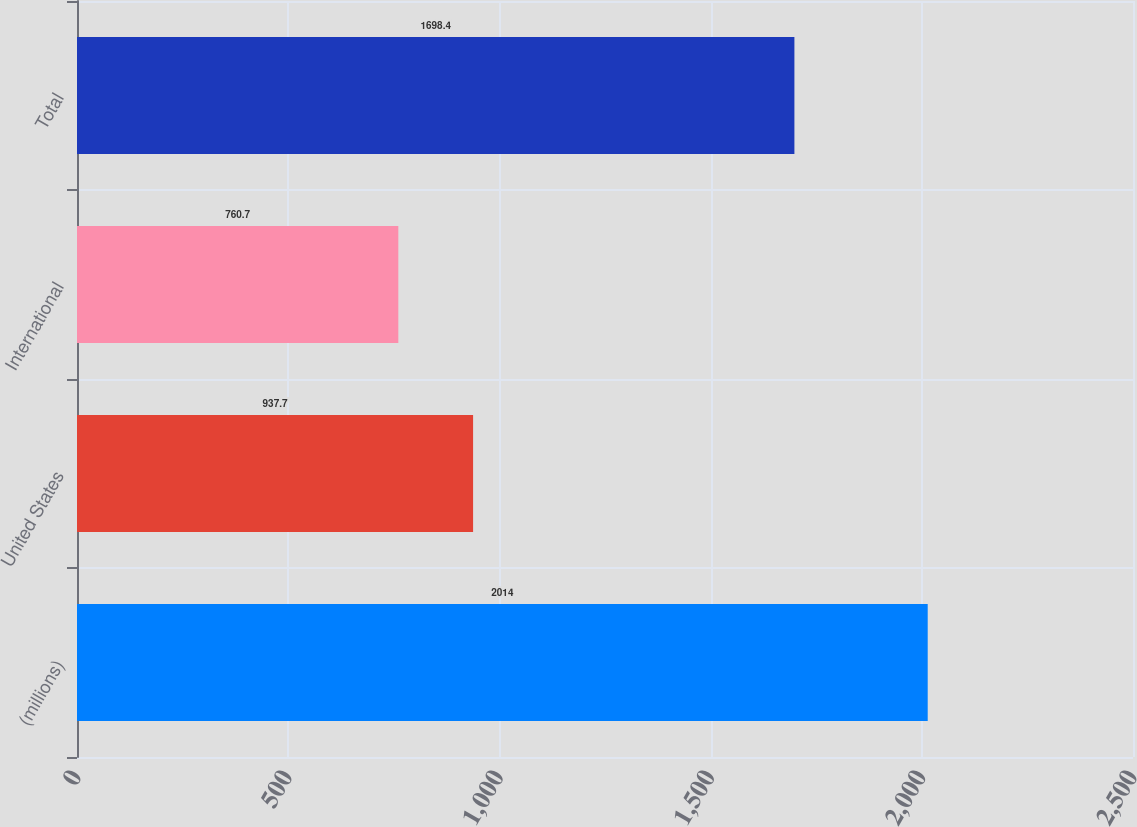<chart> <loc_0><loc_0><loc_500><loc_500><bar_chart><fcel>(millions)<fcel>United States<fcel>International<fcel>Total<nl><fcel>2014<fcel>937.7<fcel>760.7<fcel>1698.4<nl></chart> 